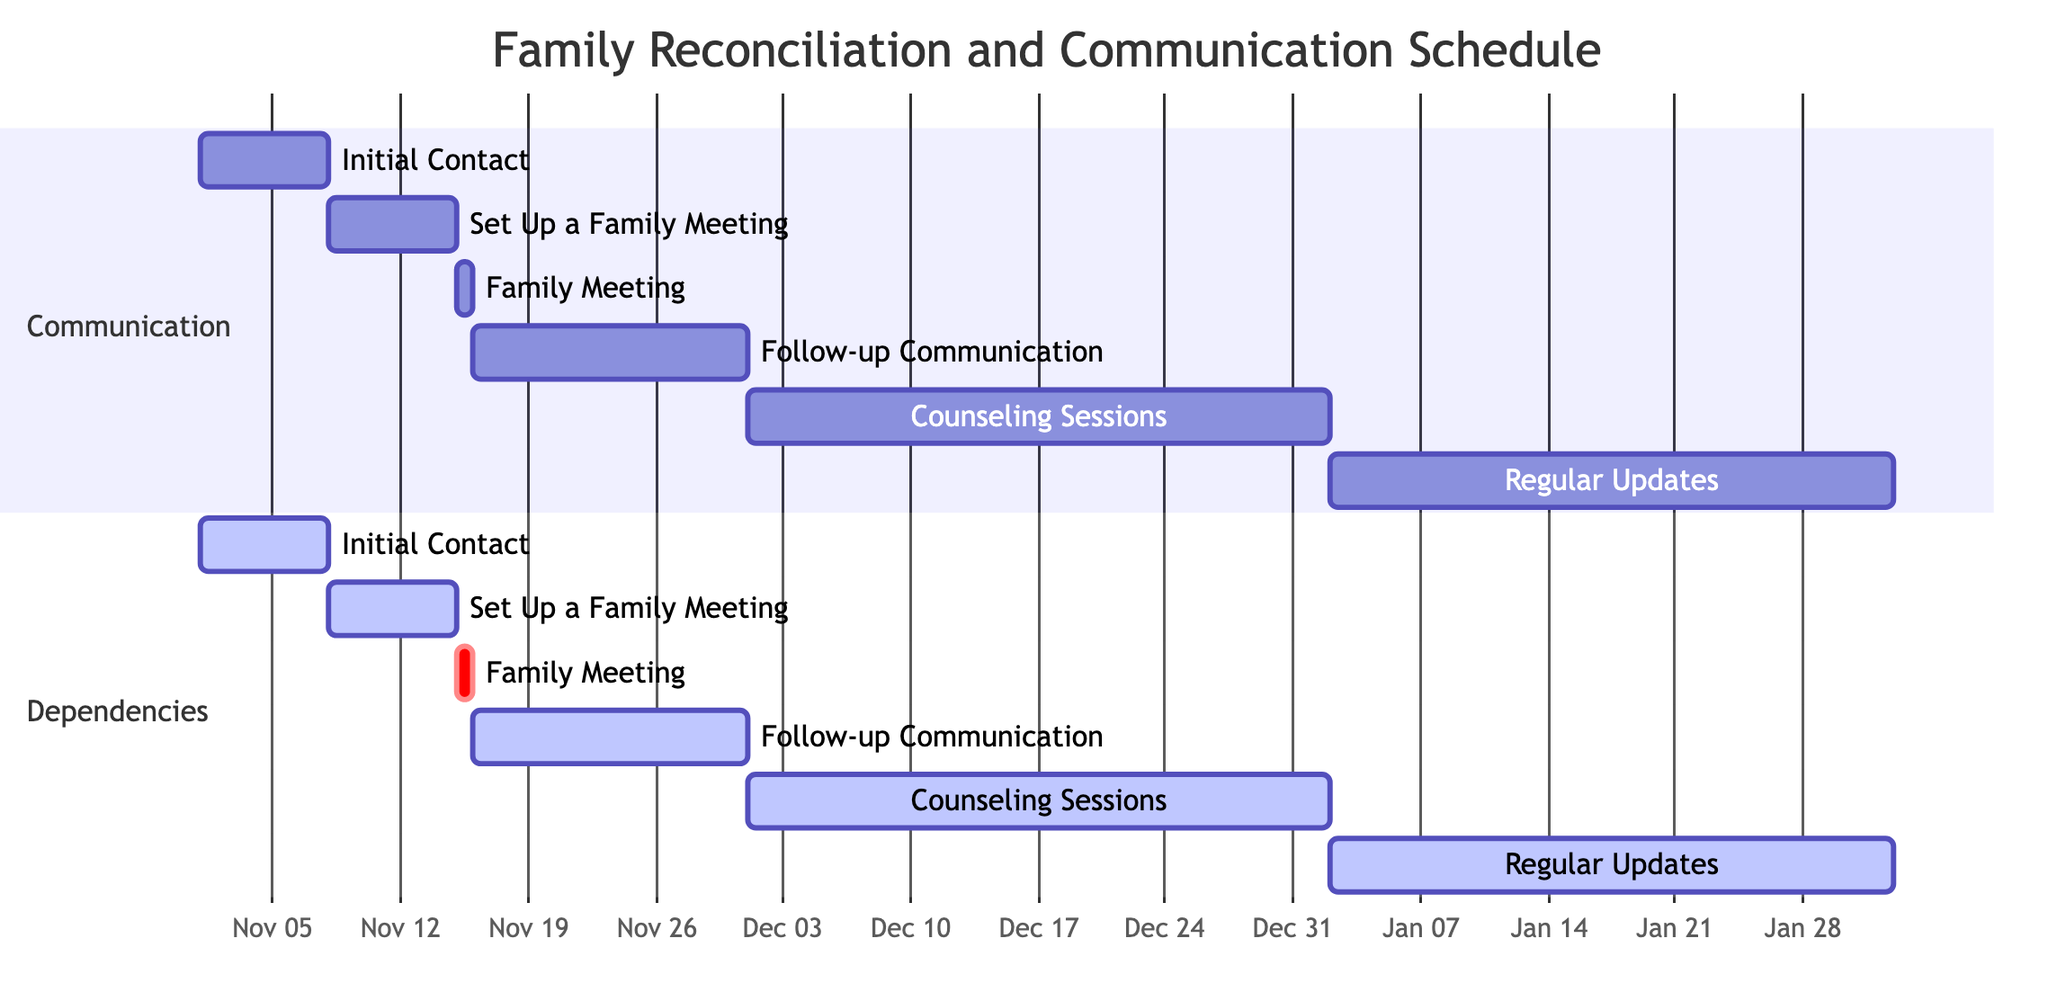What's the duration of the "Initial Contact" task? The "Initial Contact" task starts on November 1, 2023, and ends on November 7, 2023. The duration is calculated as the difference between the two dates, which is 7 days.
Answer: 7 days How many tasks are dependent on "Family Meeting"? In the diagram, the only task that follows the "Family Meeting" task is "Follow-up Communication," indicating that it is the only task that is directly dependent on it. By checking the relationships, we confirm that just one task is dependent on "Family Meeting."
Answer: 1 Which task starts the latest among the listed tasks? By examining the start dates of all tasks, "Regular Updates" begins on January 2, 2024, while the other tasks start earlier. Hence, it is the latest starting task.
Answer: Regular Updates What is the total number of tasks in the chart? By counting all the tasks listed in the Gantt chart, including all sections, we find that there are 6 tasks: Initial Contact, Set Up a Family Meeting, Family Meeting, Follow-up Communication, Counseling Sessions, and Regular Updates.
Answer: 6 Which task directly follows "Set Up a Family Meeting"? Based on the diagram structure, "Family Meeting" is scheduled immediately after "Set Up a Family Meeting." This is indicated by the dependency and sequencing of tasks.
Answer: Family Meeting What is the end date of the "Counseling Sessions" task? The "Counseling Sessions" task starts on December 1, 2023, and ends on January 1, 2024. This can be confirmed by looking at the specified start and end dates for that task in the diagram.
Answer: January 1, 2024 Which task has the shortest duration? Analyzing the durations, "Family Meeting" only takes 1 day, which is shorter than all other tasks. The length of each task is assessed by the number of days from the start to the end dates.
Answer: 1 day 